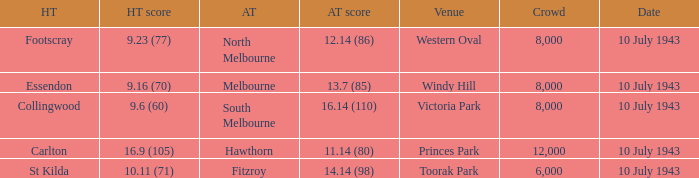When the Home team of carlton played, what was their score? 16.9 (105). 